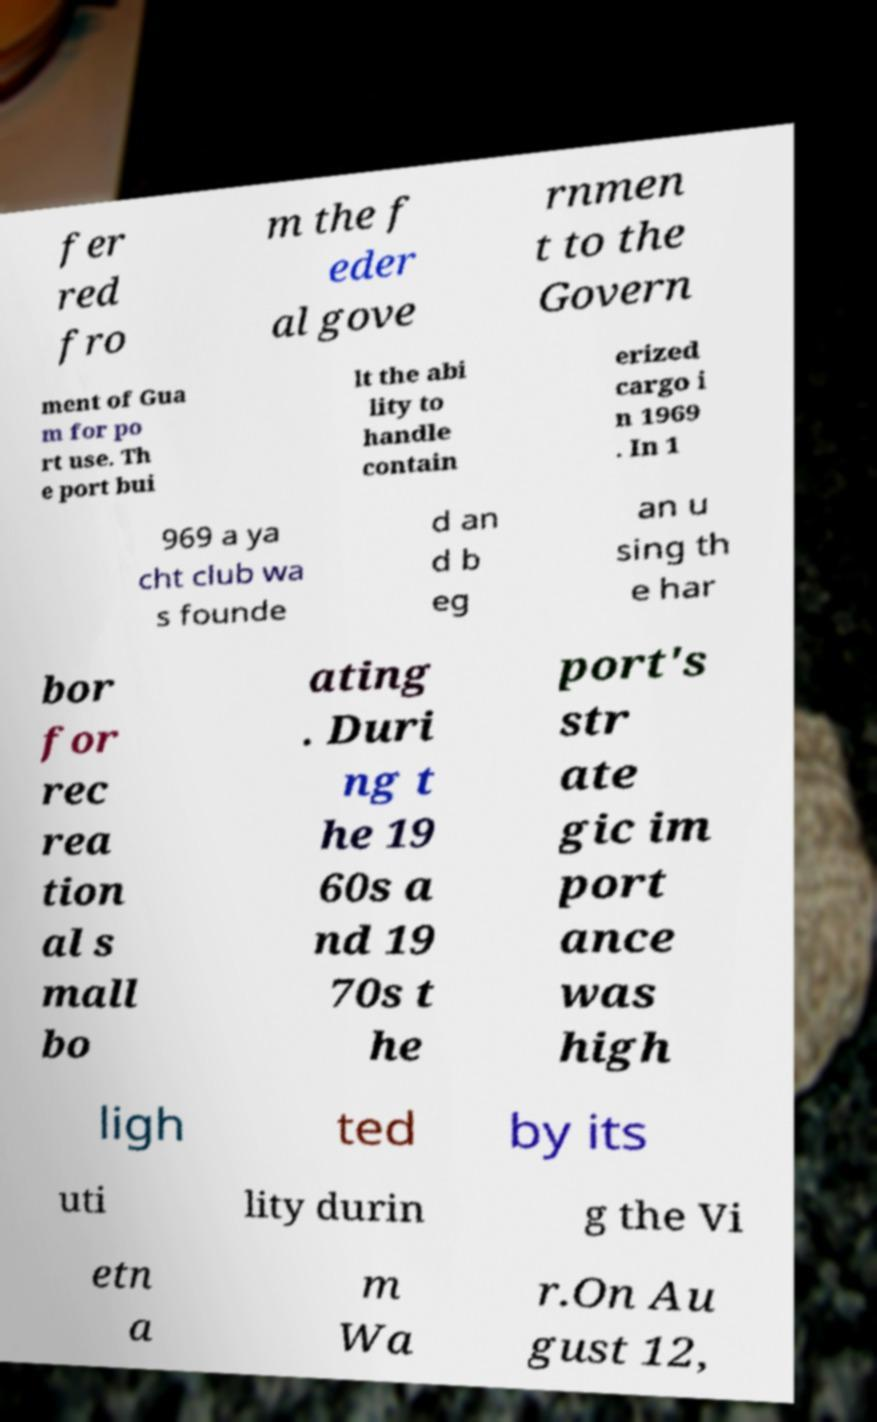Could you assist in decoding the text presented in this image and type it out clearly? fer red fro m the f eder al gove rnmen t to the Govern ment of Gua m for po rt use. Th e port bui lt the abi lity to handle contain erized cargo i n 1969 . In 1 969 a ya cht club wa s founde d an d b eg an u sing th e har bor for rec rea tion al s mall bo ating . Duri ng t he 19 60s a nd 19 70s t he port's str ate gic im port ance was high ligh ted by its uti lity durin g the Vi etn a m Wa r.On Au gust 12, 